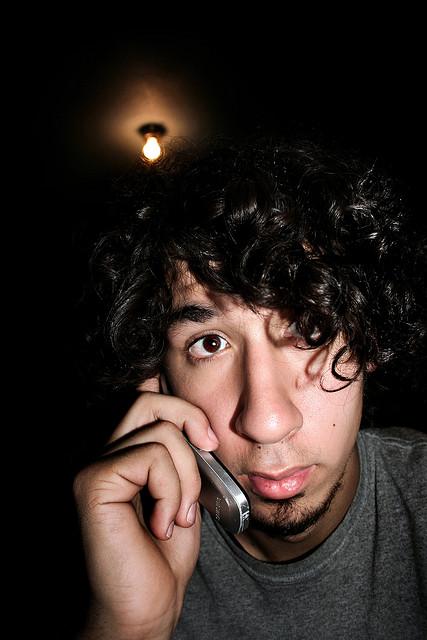Is that light on?
Be succinct. Yes. What is in his hand?
Quick response, please. Phone. Is his hair curly?
Quick response, please. Yes. 